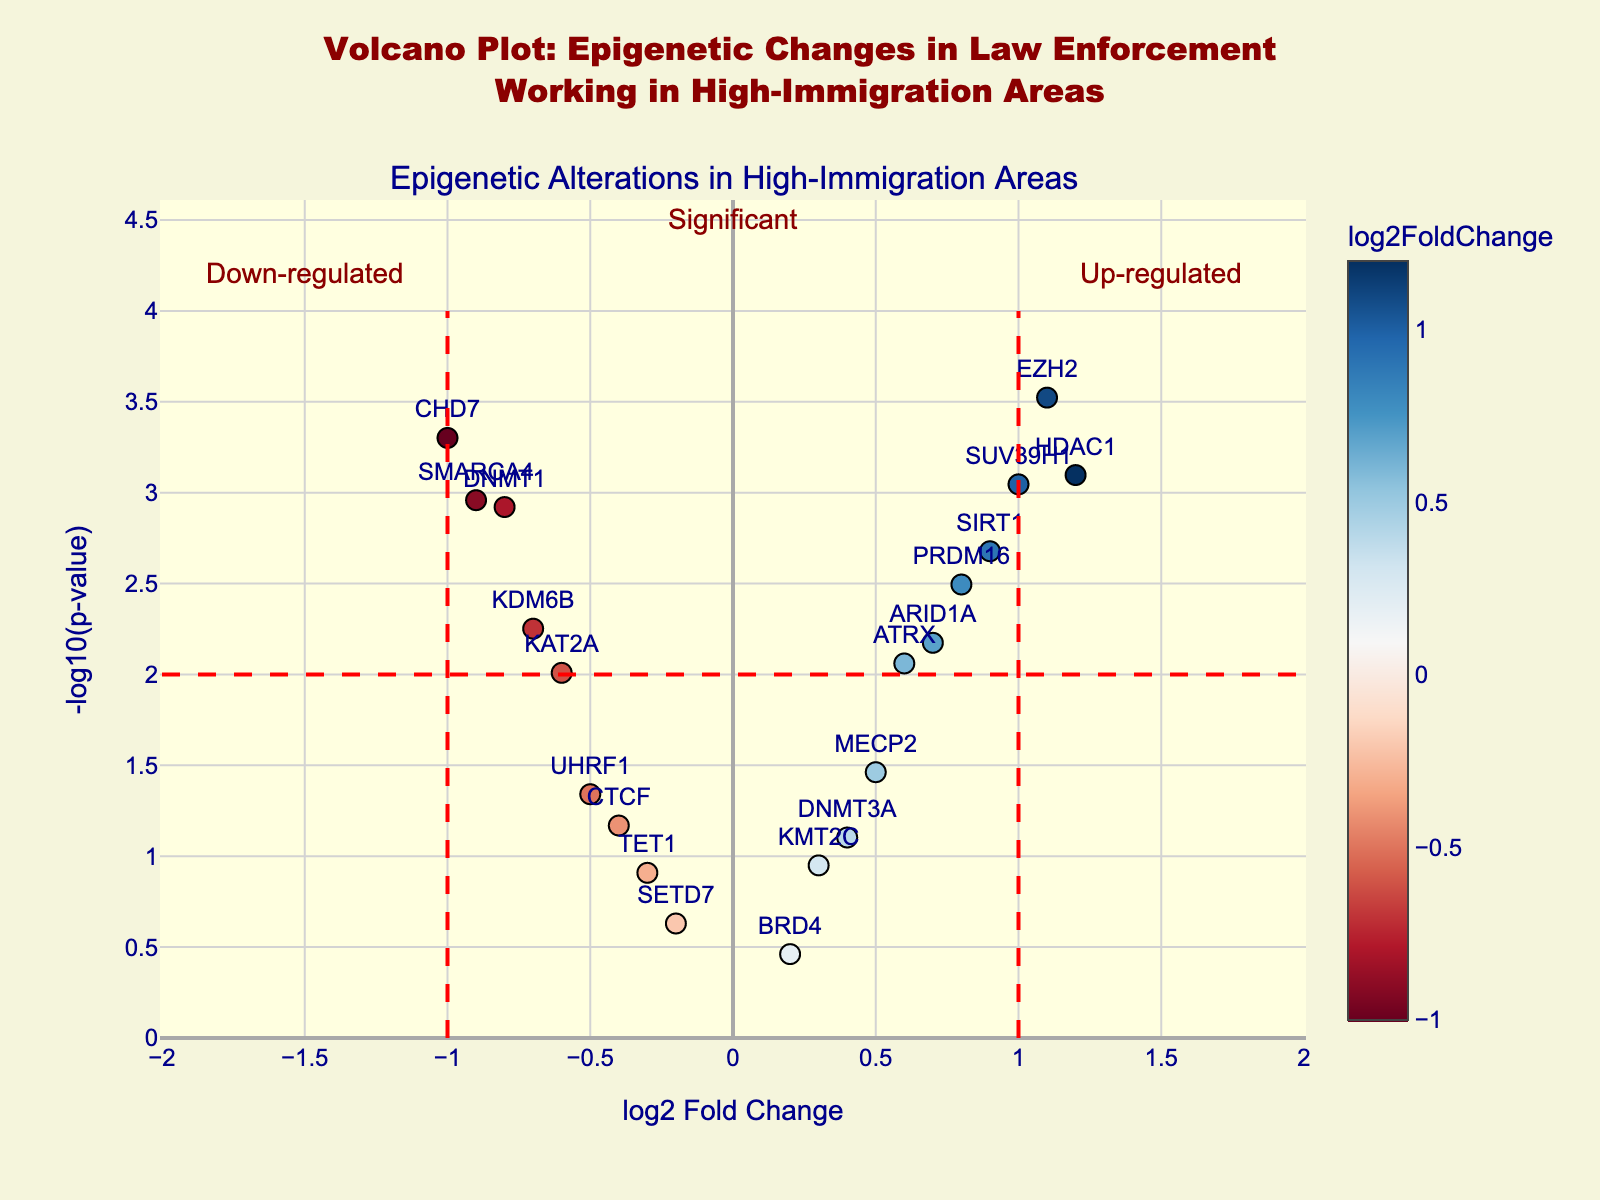What is the title of the plot? The title is displayed at the top of the figure. It reads: "Volcano Plot: Epigenetic Changes in Law Enforcement Working in High-Immigration Areas".
Answer: Volcano Plot: Epigenetic Changes in Law Enforcement Working in High-Immigration Areas What is the color scheme used in the plot? The gene markers are colored using a colorscale from red to blue, indicating the log2FoldChange values, where red represents down-regulation and blue represents up-regulation.
Answer: red to blue How many genes are significantly up-regulated? Significant genes have points above the horizontal red dashed line at -log10(p-value) = 2. Up-regulated genes have log2FoldChange > 0. SUV39H1, HDAC1, SIRT1, EZH2, and PRDM16 are above both thresholds.
Answer: 5 Which gene has the highest log2 fold change and what is its p-value? By looking at the positioning along the x-axis, HDAC1 has the highest log2 fold change at 1.2. Check the hover text for its p-value, which is 0.0008.
Answer: HDAC1, 0.0008 How many genes are significantly down-regulated? Significant genes have points above the horizontal red dashed line at -log10(p-value) = 2. Down-regulated genes have log2FoldChange < 0. DNMT1, KDM6B, CHD7, and SMARCA4 are above both thresholds.
Answer: 4 What is the log2FoldChange value for gene ATRX? Find ATRX in the plot, then refer to its hover text or positioning. It has a log2FoldChange of 0.6.
Answer: 0.6 Are there more genes that are significantly up-regulated or down-regulated? Count the points above the threshold lines. There are 5 up-regulated and 4 down-regulated genes, meaning there are more significantly up-regulated genes.
Answer: up-regulated Which gene has the lowest p-value and what is its log2 fold change? The lowest p-value corresponds to the highest point on the y-axis. EZH2 is the highest point, having a p-value of 0.0003 and a log2FoldChange of 1.1.
Answer: EZH2, 1.1 What color represents the gene CHD7? Find CHD7 in the plot and note its color. It is red, indicating a negative log2 fold change (down-regulation).
Answer: red Are there any genes with a p-value above 0.05, and if so, what are they? -log10(0.05) is approximately 1.3. Any points below this threshold have a p-value above 0.05. CTCF, SETD7, and BRD4 fit this criterion.
Answer: CTCF, SETD7, BRD4 